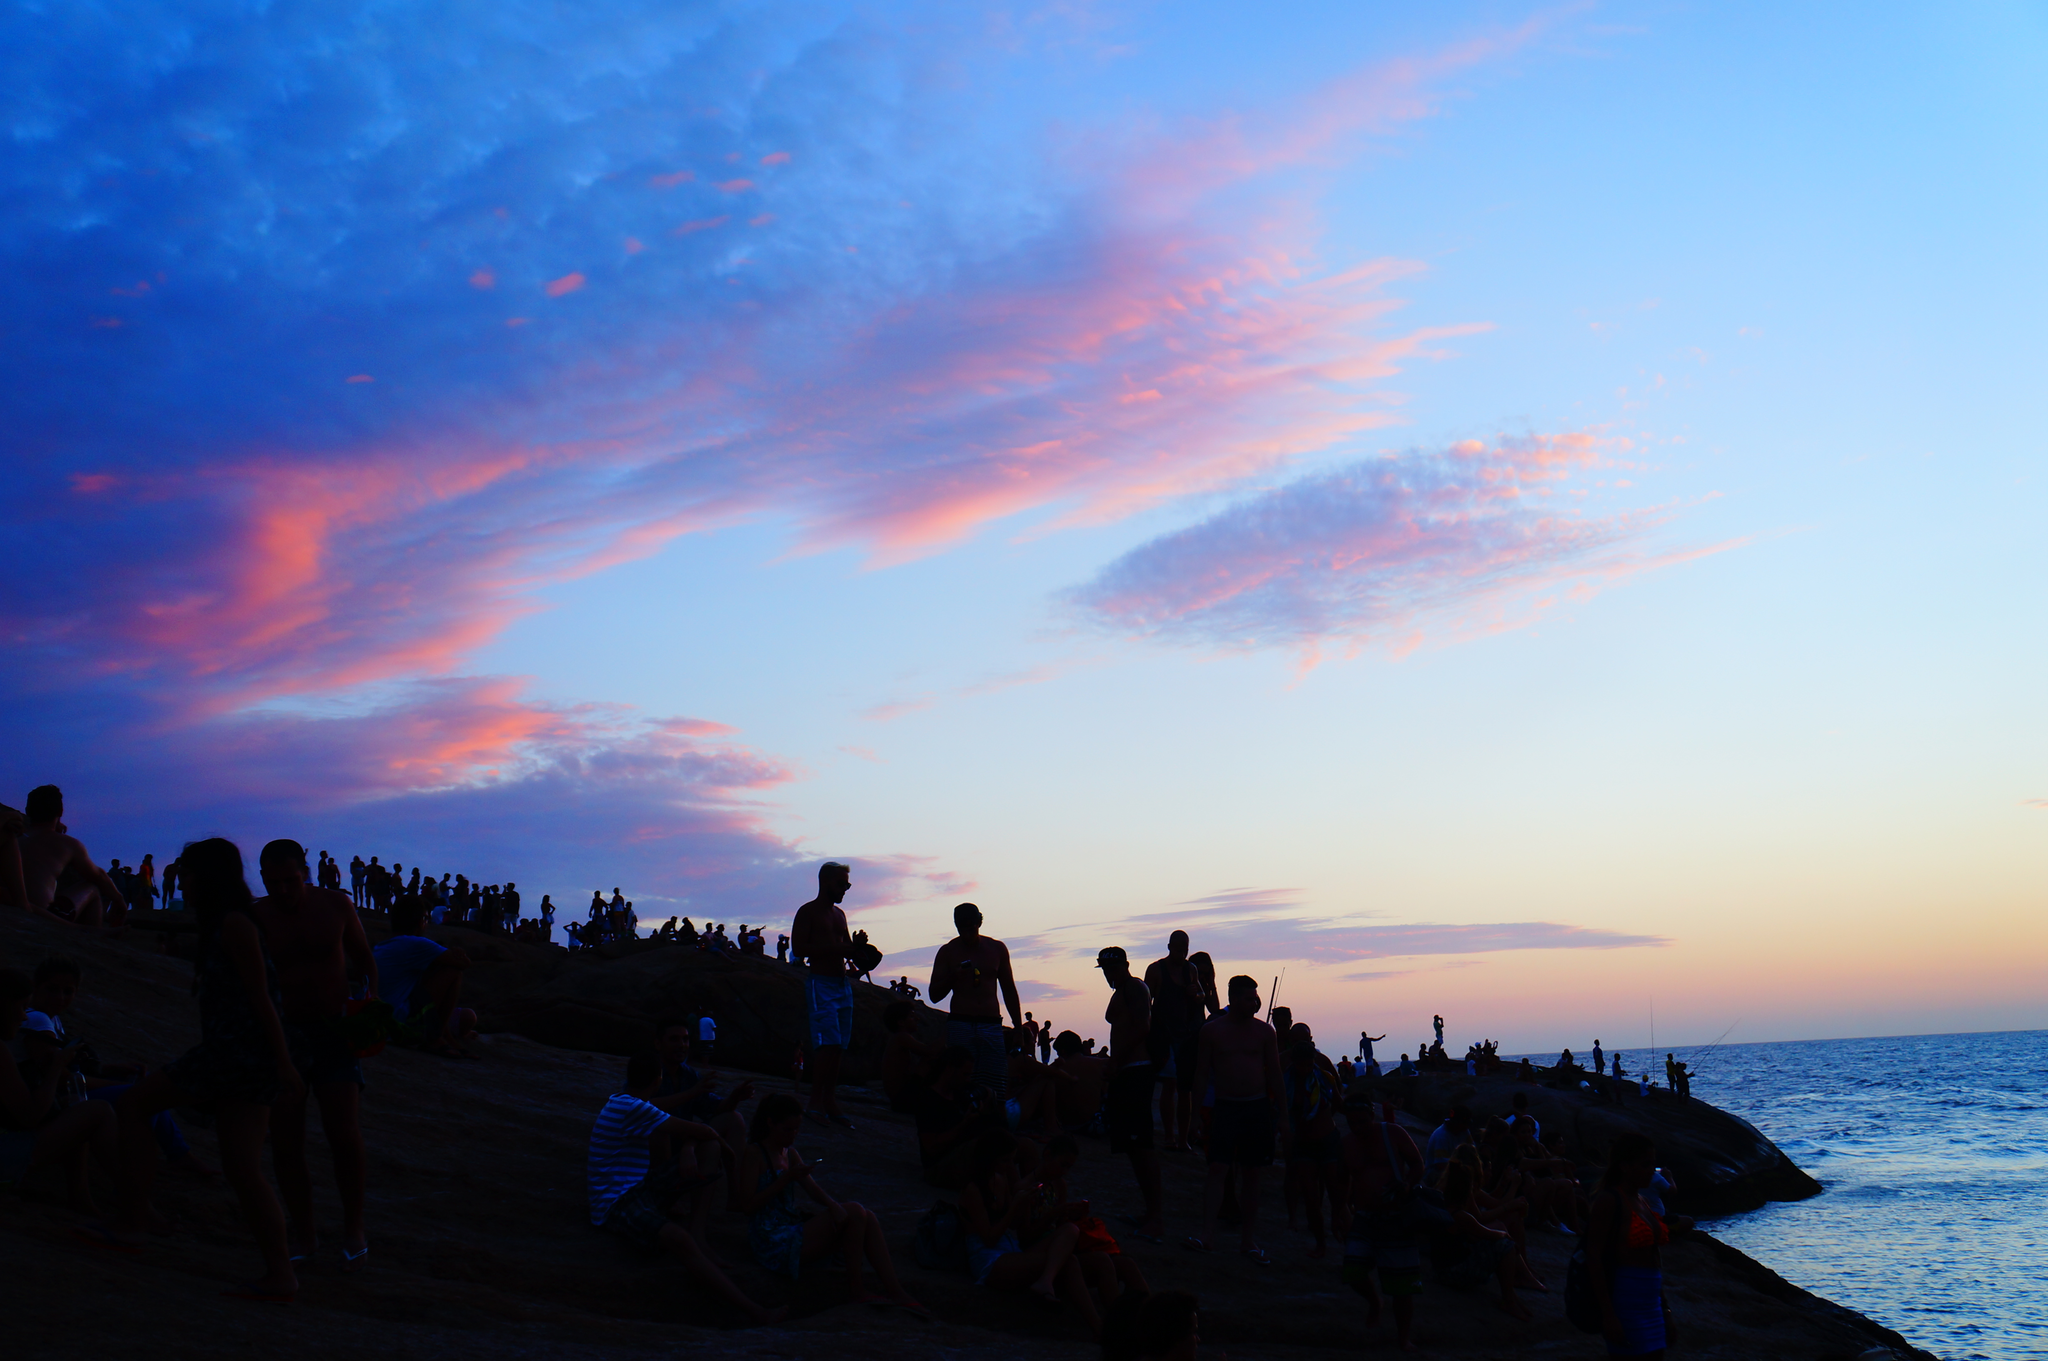Describe this image in one or two sentences. This picture is taken during the sun set. In this image there is water on the right side. On the left side there is a land on which there are so many people standing on it. 